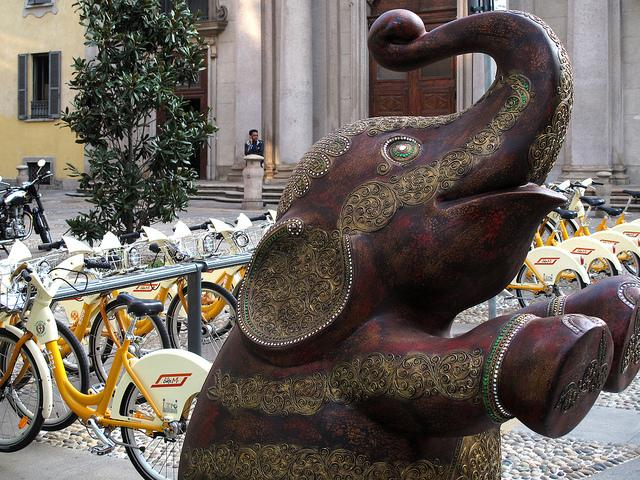The statue best represents who?

Choices:
A) thor
B) ganesh
C) hades
D) anubis ganesh 